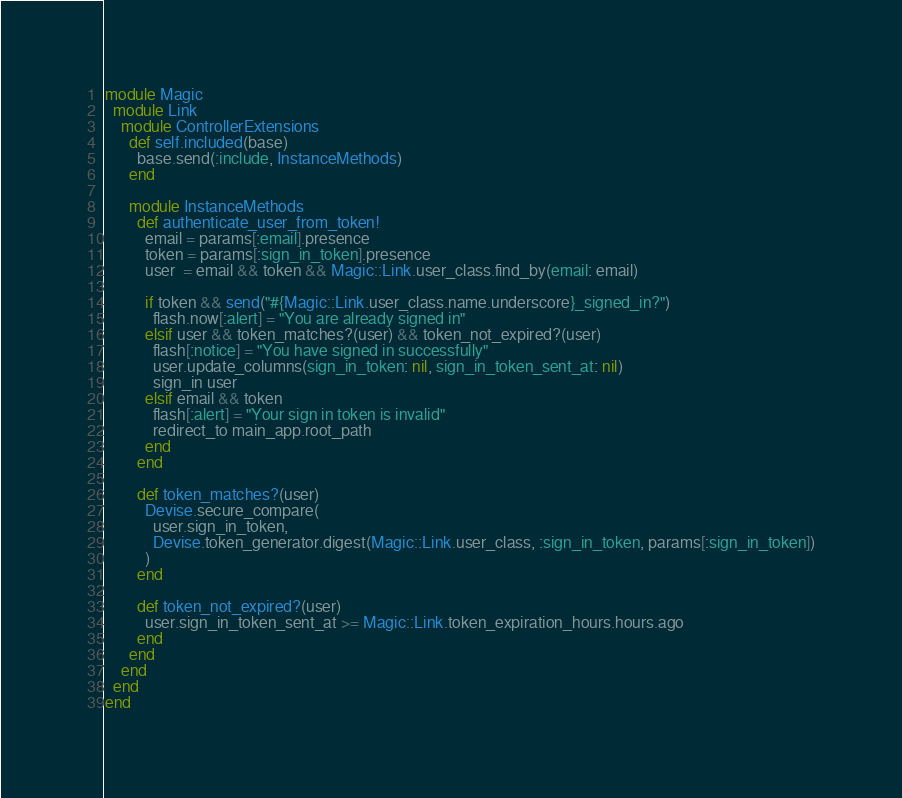Convert code to text. <code><loc_0><loc_0><loc_500><loc_500><_Ruby_>module Magic
  module Link
    module ControllerExtensions
      def self.included(base)
        base.send(:include, InstanceMethods)
      end

      module InstanceMethods
        def authenticate_user_from_token!
          email = params[:email].presence
          token = params[:sign_in_token].presence
          user  = email && token && Magic::Link.user_class.find_by(email: email)

          if token && send("#{Magic::Link.user_class.name.underscore}_signed_in?")
            flash.now[:alert] = "You are already signed in"
          elsif user && token_matches?(user) && token_not_expired?(user)
            flash[:notice] = "You have signed in successfully"
            user.update_columns(sign_in_token: nil, sign_in_token_sent_at: nil)
            sign_in user
          elsif email && token
            flash[:alert] = "Your sign in token is invalid"
            redirect_to main_app.root_path
          end
        end

        def token_matches?(user)
          Devise.secure_compare(
            user.sign_in_token,
            Devise.token_generator.digest(Magic::Link.user_class, :sign_in_token, params[:sign_in_token])
          )
        end

        def token_not_expired?(user)
          user.sign_in_token_sent_at >= Magic::Link.token_expiration_hours.hours.ago
        end
      end
    end
  end
end
</code> 